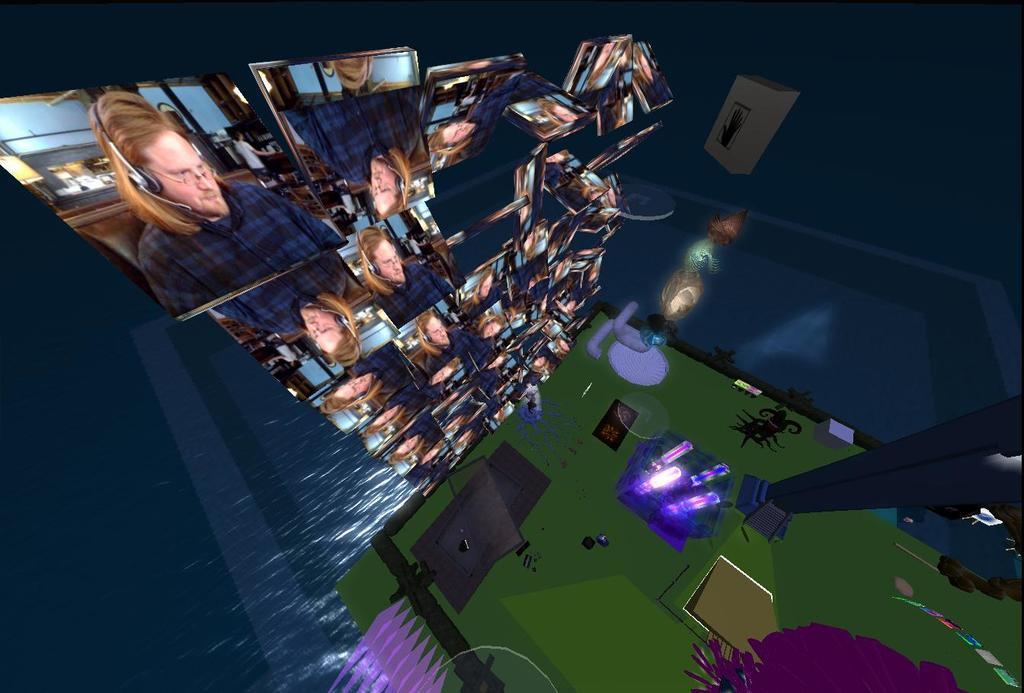Can you describe this image briefly? This is an inside picture of the room, on the left side of the image we can see a screen with images, there are some objects like pillar, lights, box and some other objects on the floor, also we can see the wall. 